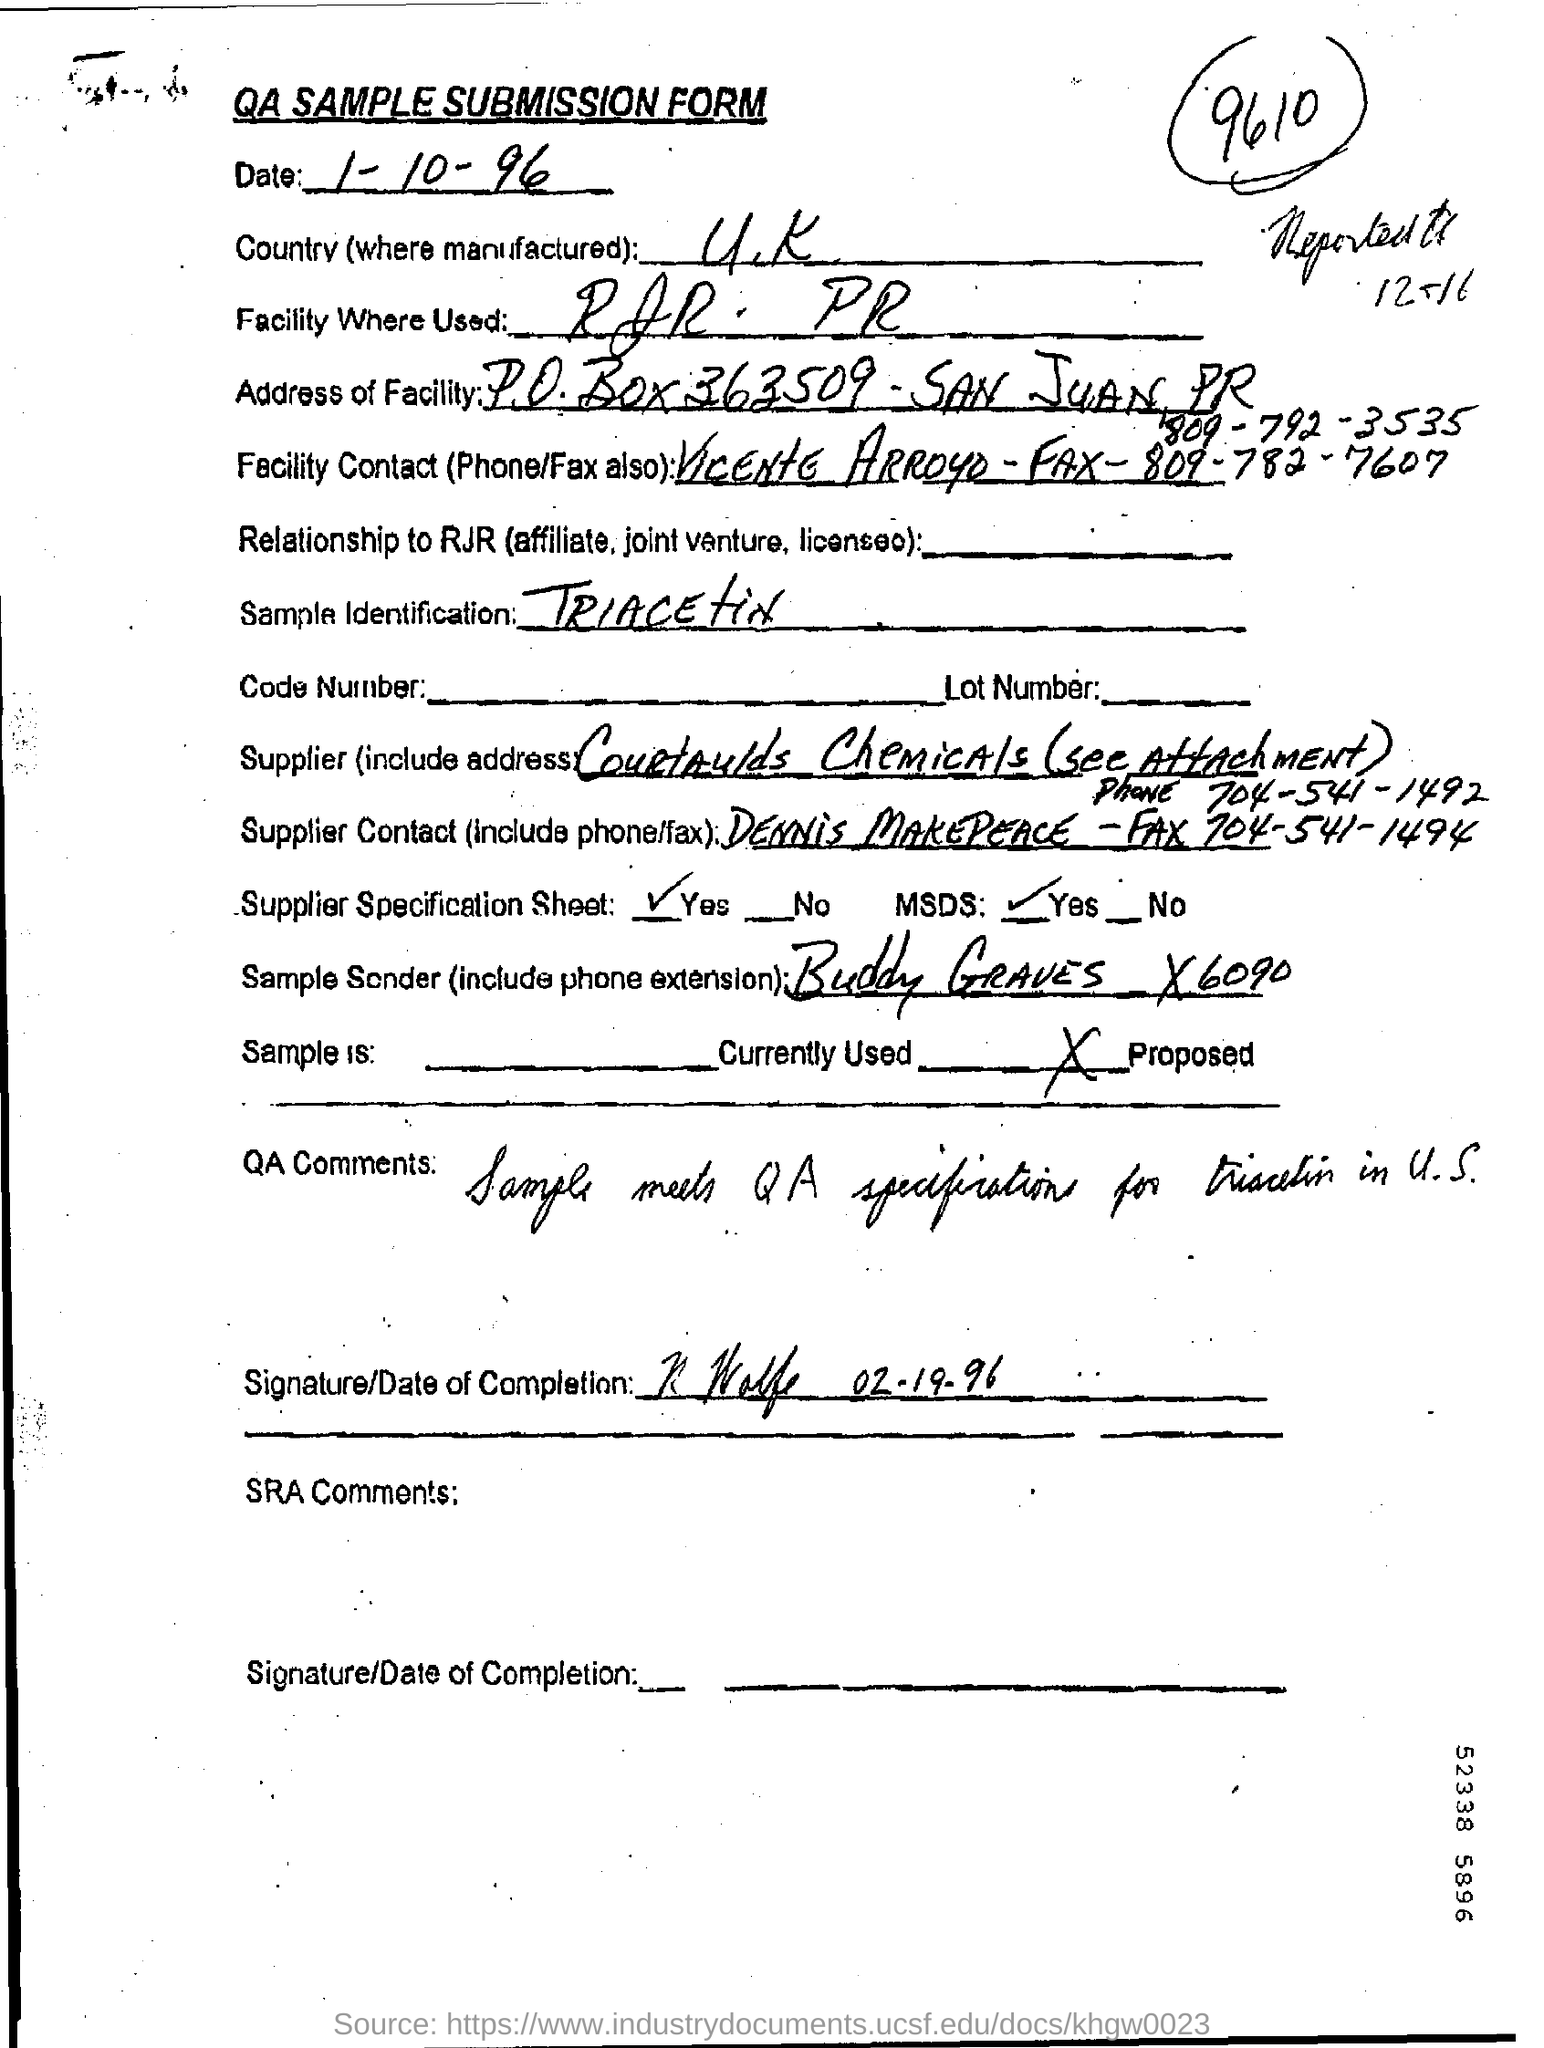What is the Date?
Keep it short and to the point. 1-10-96. Where is the Country (where manufactured)?
Offer a very short reply. U.K. What is the sample identification?
Your answer should be compact. Triacetin. Who is the sample sender?
Provide a succinct answer. Buddy Graves. Who is the Supplier Contact?
Make the answer very short. DENNIS MAKEPEACE. 